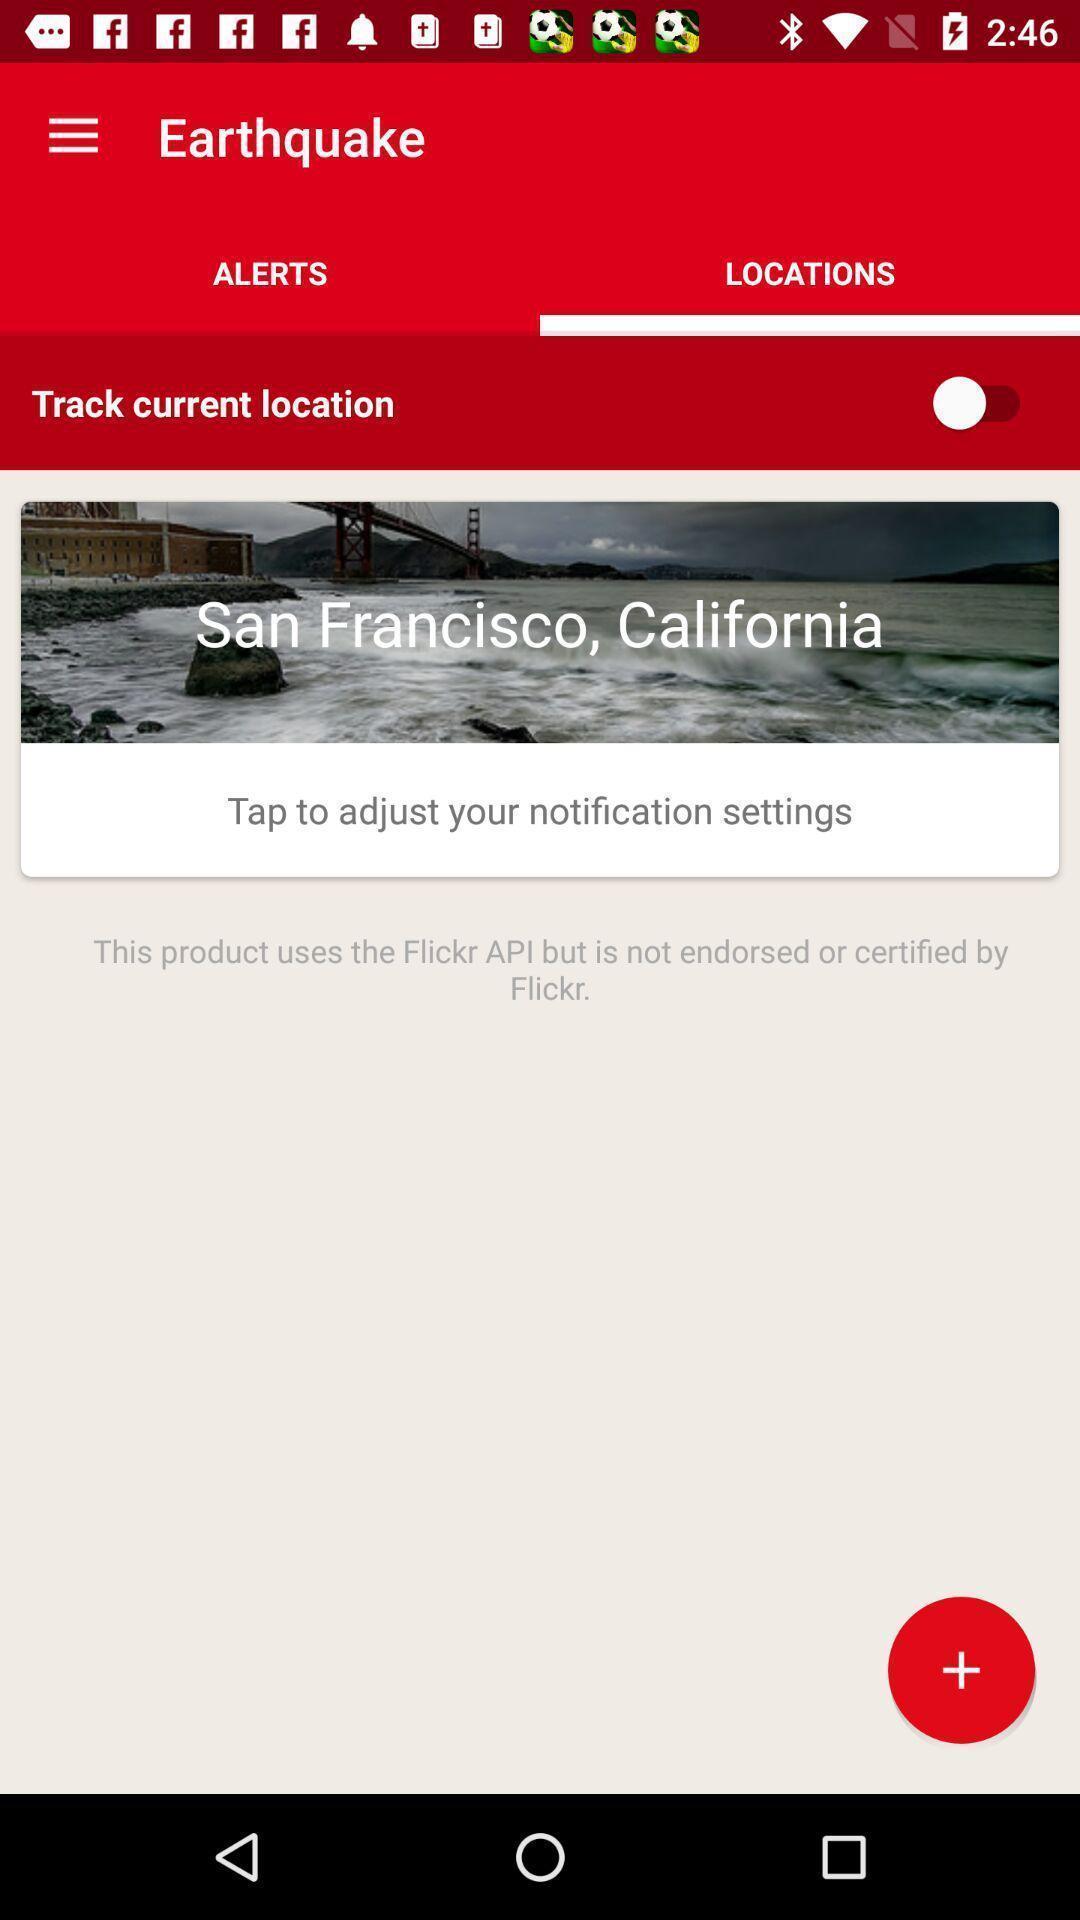Give me a narrative description of this picture. Screen showing locations page. 